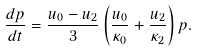<formula> <loc_0><loc_0><loc_500><loc_500>\frac { d p } { d t } = \frac { u _ { 0 } - u _ { 2 } } { 3 } \left ( \frac { u _ { 0 } } { \kappa _ { 0 } } + \frac { u _ { 2 } } { \kappa _ { 2 } } \right ) p .</formula> 